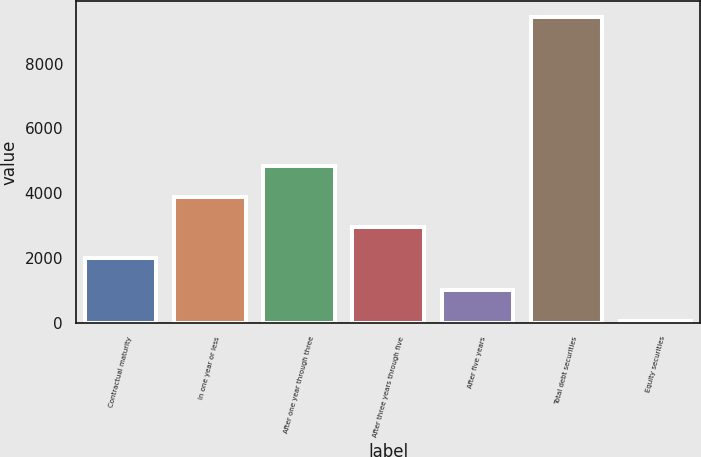Convert chart. <chart><loc_0><loc_0><loc_500><loc_500><bar_chart><fcel>Contractual maturity<fcel>In one year or less<fcel>After one year through three<fcel>After three years through five<fcel>After five years<fcel>Total debt securities<fcel>Equity securities<nl><fcel>2008<fcel>3885.6<fcel>4824.4<fcel>2946.8<fcel>995.8<fcel>9445<fcel>57<nl></chart> 